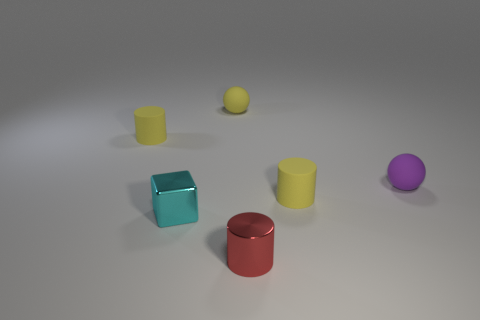How many metal things are tiny cyan cubes or red objects?
Your answer should be very brief. 2. There is a metallic object on the left side of the small red metal thing; what is its color?
Keep it short and to the point. Cyan. There is a red shiny object that is the same size as the purple sphere; what shape is it?
Provide a short and direct response. Cylinder. There is a small metal cylinder; does it have the same color as the tiny cylinder that is right of the red metallic thing?
Ensure brevity in your answer.  No. What number of things are small cylinders on the left side of the tiny cyan thing or yellow cylinders on the left side of the metal cylinder?
Give a very brief answer. 1. There is a red object that is the same size as the cyan cube; what is its material?
Give a very brief answer. Metal. What number of other things are made of the same material as the yellow ball?
Your answer should be compact. 3. Do the tiny red thing that is on the right side of the tiny cyan metal object and the small metallic object that is to the left of the tiny red metal cylinder have the same shape?
Provide a short and direct response. No. What color is the tiny matte ball that is right of the small matte cylinder in front of the object that is to the left of the cyan metal object?
Make the answer very short. Purple. Are there fewer cylinders than purple balls?
Ensure brevity in your answer.  No. 